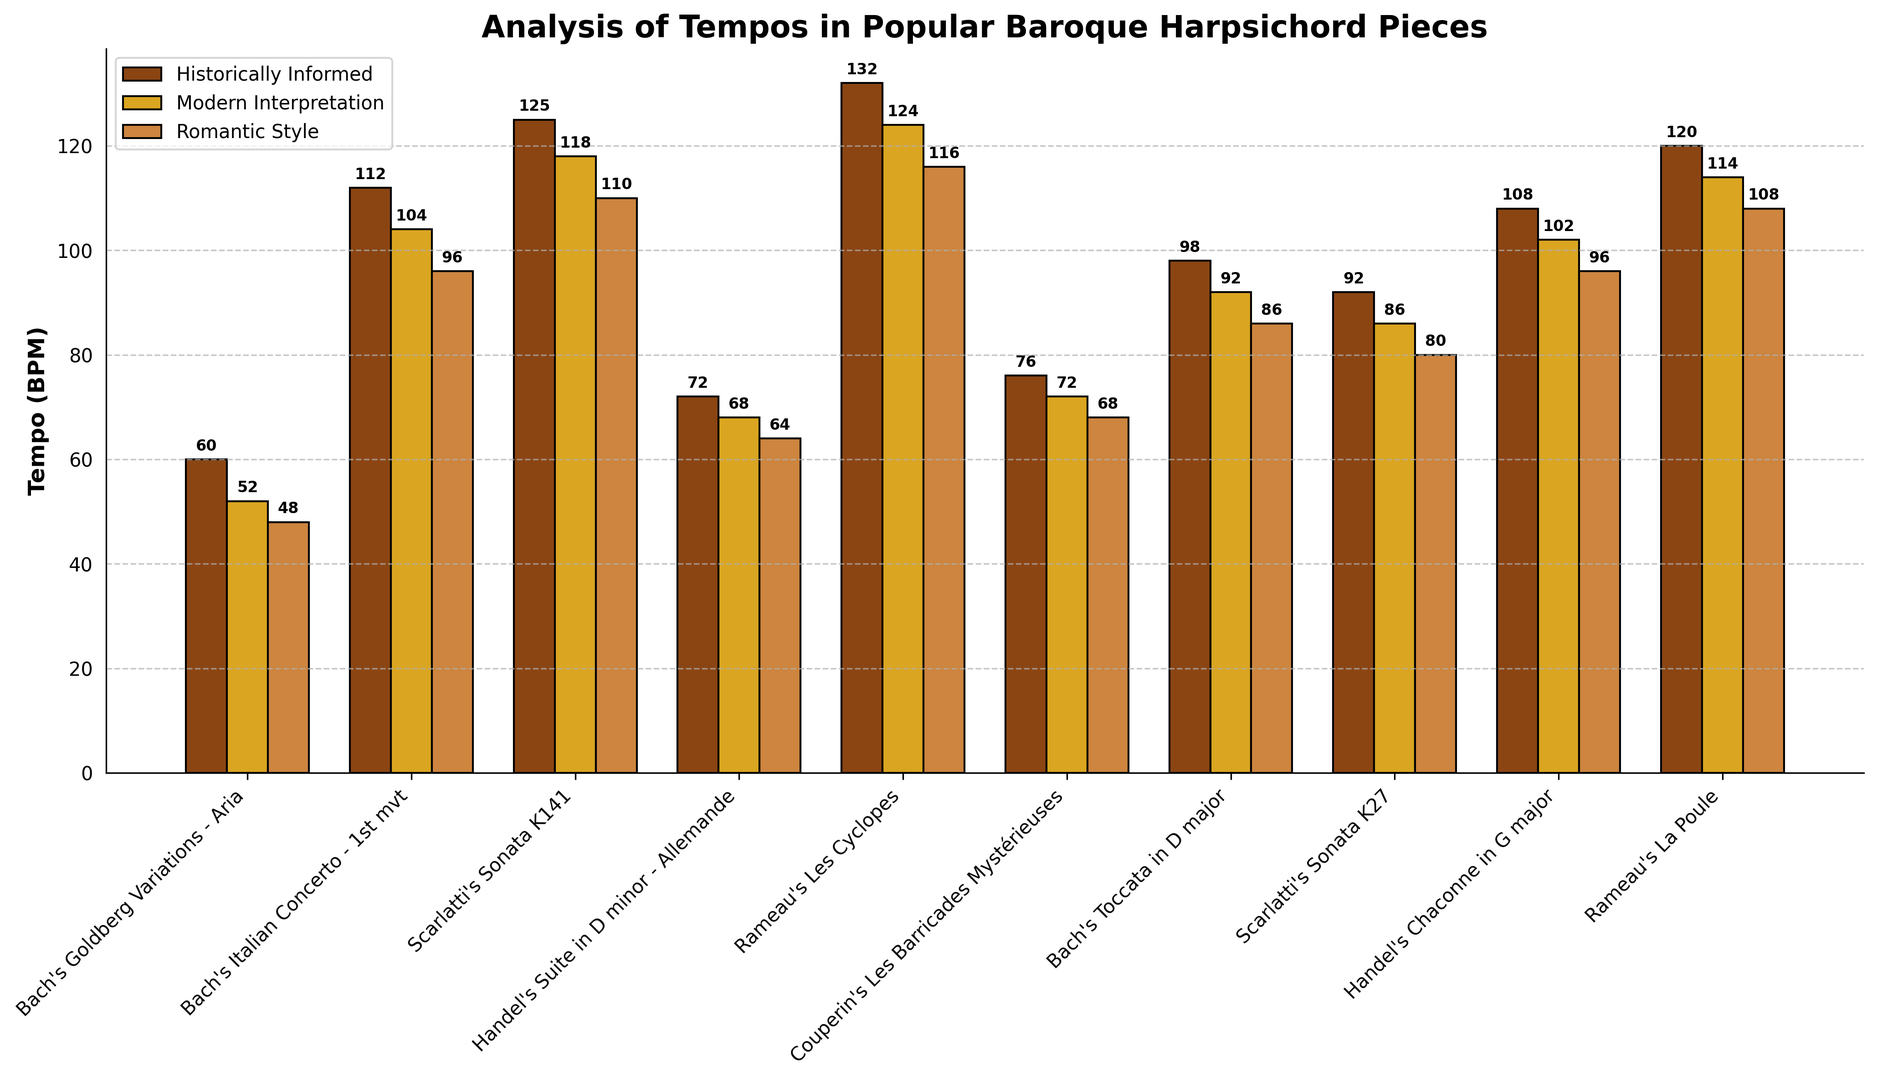What's the difference in tempo between Historically Informed and Romantic Style for Rameau's Les Cyclopes? To find the difference in tempo between Historically Informed and Romantic Style for Rameau's Les Cyclopes, subtract the tempo value of Romantic Style from Historically Informed. The values are 132 and 116 respectively. So, 132 - 116 = 16.
Answer: 16 Which piece has the fastest tempo in Historically Informed style? Look for the piece with the highest bar in the Historically Informed style. Rameau's Les Cyclopes has the highest bar with a tempo of 132 BPM.
Answer: Rameau's Les Cyclopes What is the average tempo of the Modern Interpretation style for Bach's pieces? Identify and sum the tempos of Bach's pieces in Modern Interpretation style (52+104+92+86), and then divide by the number of pieces (4). The sum is 334 BPM, so 334 / 4 = 83.5.
Answer: 83.5 BPM Which style has the slowest tempo for Couperin's Les Barricades Mystérieuses? Compare the heights of the bars for the three styles for Couperin's Les Barricades Mystérieuses. The Romantic Style has the lowest bar with a tempo of 68 BPM.
Answer: Romantic Style Is the tempo of Handel's Suite in D minor - Allemande faster in Historically Informed or Modern Interpretation style? Compare the heights of the bars for Historically Informed and Modern Interpretation styles for Handel's Suite in D minor - Allemande. Historically Informed has a tempo of 72 BPM, while Modern Interpretation has 68 BPM. Since 72 > 68, it's faster in Historically Informed.
Answer: Historically Informed What is the total tempo for all pieces in Romantic Style? Sum the tempo values of all pieces in the Romantic Style: 48+96+110+64+116+68+86+80+96+108 = 872 BPM.
Answer: 872 BPM Which piece has a greater tempo difference between Historically Informed and Modern Interpretation styles, Bach's Italian Concerto - 1st mvt or Handel's Chaconne in G major? Calculate the tempo differences: For Bach's Italian Concerto - 1st mvt, it's 112 - 104 = 8. For Handel's Chaconne in G major, it's 108 - 102 = 6. So, Bach's Italian Concerto - 1st mvt has a greater tempo difference.
Answer: Bach's Italian Concerto - 1st mvt In which piece is the tempo difference between Historically Informed and Modern Interpretation closest to the difference in tempo between Modern Interpretation and Romantic Style for Bach's Goldberg Variations - Aria? Calculate the tempo differences for both conditions: Bach's Goldberg Variations - Aria's difference between Modern Interpretation and Romantic Style is 52 - 48 = 4. Compare this with all pieces for the difference between Historically Informed and Modern Interpretation (e.g., 60 - 52 = 8, 104 - 96 = 8, 118 - 110 = 8, etc.). After comparison, none exactly match the difference of 4, but the smallest difference difference is Couperin's Les Barricades Mystérieuses with 4.
Answer: Couperin's Les Barricades Mystérieuses 